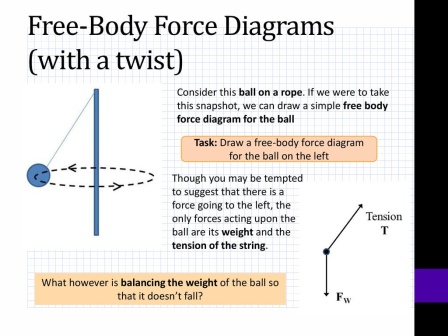What considerations should one have while drawing a free-body diagram for the swinging ball? When drawing a free-body diagram for a swinging ball, key considerations include identifying all the forces acting on the ball and their respective directions. These forces commonly include tension (T) from the rope, acting along the line of the rope, and the weight (Fw) due to gravity, acting downwards. It’s important to accurately represent these forces' magnitudes and directions even if the ball seems to move in a curved path, assuming the instant snapshot captures a specific moment of the swing. Additionally, ensure the forces are depicted with correct proportional lengths and angles to maintain the physical accuracy and clarify the dynamic interaction affecting the ball. Can you also explain how the tension and weight factors influence the motion of the ball? Certainly! The tension force (T) in the rope works to keep the ball attached and constrains its motion along a circular path. This force adapts in magnitude and direction based on the ball's position and speed, always pointing towards the pivot. On the other hand, the weight of the ball (Fw), which is the force of gravity, acts constantly downward. During the ball's swing, it moves through different positions where the interplay between these forces determines its trajectory. When the ball is at its lowest point, tension is at its maximum, counteracting not just gravity but the additional centripetal force needed to maintain the circular motion. At the extremes of the swing, the tension reduces and gravity aims to pull the ball back down, converting potential energy to kinetic energy and vice versa, sustaining the swing’s oscillatory motion. Can you envision a creative scenario involving the ball and illustrating an unusual application of these principles? Imagine a futuristic theme park where rides are designed to teach physics principles! In one special attraction, visitors experience the 'Pendulum of Knowledge,' a giant swinging ball akin to the one depicted. As they swing, they pass through interactive holographic panels that show real-time calculations of the forces at play. Rather than just observing, riders are quizzed on their understanding of tension and gravity, with correct answers boosting their height and speed on the swing! This immersive experience not only thrills but also deepens comprehension of free-body diagrams and the forces behind pendular motion. 